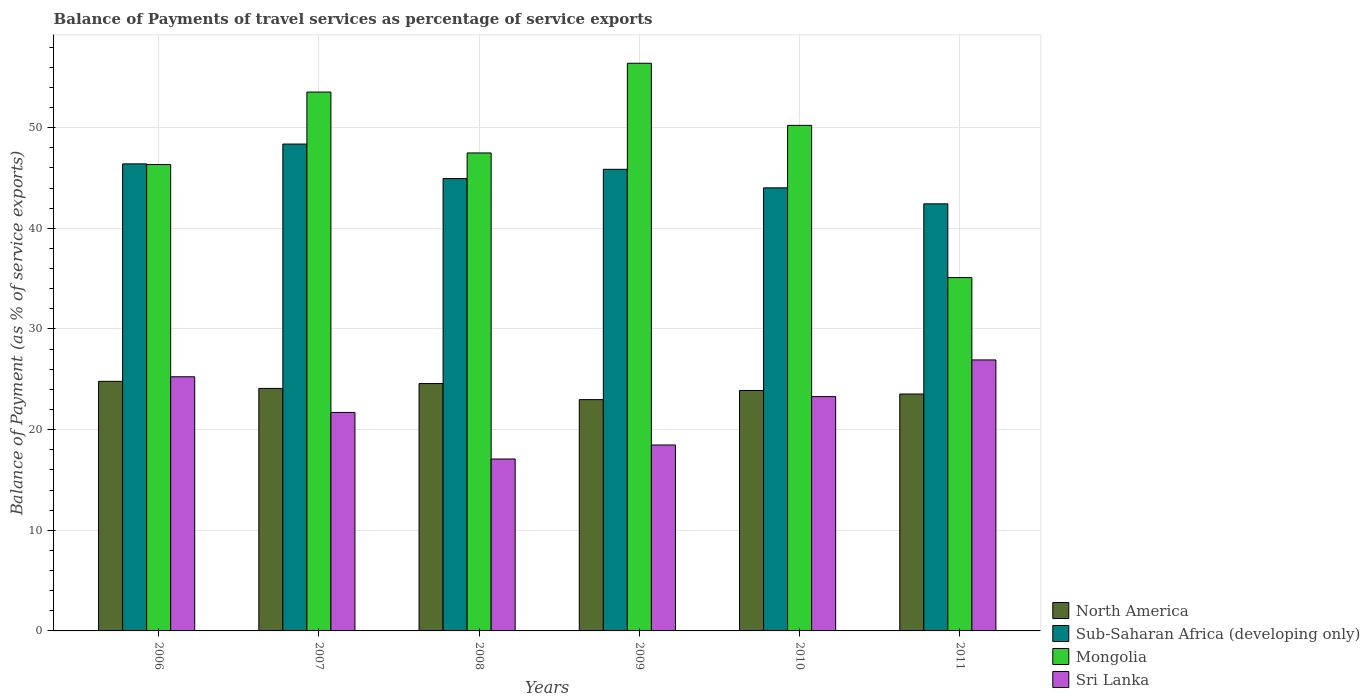How many different coloured bars are there?
Provide a short and direct response. 4. Are the number of bars per tick equal to the number of legend labels?
Make the answer very short. Yes. How many bars are there on the 1st tick from the right?
Offer a terse response. 4. In how many cases, is the number of bars for a given year not equal to the number of legend labels?
Your answer should be very brief. 0. What is the balance of payments of travel services in North America in 2009?
Provide a succinct answer. 22.98. Across all years, what is the maximum balance of payments of travel services in Sri Lanka?
Your answer should be compact. 26.92. Across all years, what is the minimum balance of payments of travel services in Sri Lanka?
Keep it short and to the point. 17.08. In which year was the balance of payments of travel services in Sub-Saharan Africa (developing only) maximum?
Provide a short and direct response. 2007. What is the total balance of payments of travel services in Sri Lanka in the graph?
Provide a succinct answer. 132.71. What is the difference between the balance of payments of travel services in Mongolia in 2007 and that in 2008?
Your answer should be very brief. 6.05. What is the difference between the balance of payments of travel services in Sub-Saharan Africa (developing only) in 2007 and the balance of payments of travel services in North America in 2009?
Provide a succinct answer. 25.39. What is the average balance of payments of travel services in North America per year?
Make the answer very short. 23.98. In the year 2009, what is the difference between the balance of payments of travel services in Mongolia and balance of payments of travel services in North America?
Your answer should be very brief. 33.42. In how many years, is the balance of payments of travel services in North America greater than 18 %?
Your answer should be compact. 6. What is the ratio of the balance of payments of travel services in Mongolia in 2006 to that in 2008?
Offer a very short reply. 0.98. Is the difference between the balance of payments of travel services in Mongolia in 2009 and 2010 greater than the difference between the balance of payments of travel services in North America in 2009 and 2010?
Ensure brevity in your answer.  Yes. What is the difference between the highest and the second highest balance of payments of travel services in Sri Lanka?
Provide a short and direct response. 1.67. What is the difference between the highest and the lowest balance of payments of travel services in Mongolia?
Offer a terse response. 21.29. Is the sum of the balance of payments of travel services in Sub-Saharan Africa (developing only) in 2007 and 2010 greater than the maximum balance of payments of travel services in North America across all years?
Offer a terse response. Yes. What does the 4th bar from the left in 2007 represents?
Offer a terse response. Sri Lanka. What does the 4th bar from the right in 2009 represents?
Your answer should be very brief. North America. Is it the case that in every year, the sum of the balance of payments of travel services in Sub-Saharan Africa (developing only) and balance of payments of travel services in Mongolia is greater than the balance of payments of travel services in North America?
Your response must be concise. Yes. How many bars are there?
Keep it short and to the point. 24. Are the values on the major ticks of Y-axis written in scientific E-notation?
Offer a terse response. No. Does the graph contain grids?
Provide a short and direct response. Yes. What is the title of the graph?
Your answer should be very brief. Balance of Payments of travel services as percentage of service exports. What is the label or title of the X-axis?
Keep it short and to the point. Years. What is the label or title of the Y-axis?
Offer a very short reply. Balance of Payment (as % of service exports). What is the Balance of Payment (as % of service exports) in North America in 2006?
Give a very brief answer. 24.8. What is the Balance of Payment (as % of service exports) of Sub-Saharan Africa (developing only) in 2006?
Offer a very short reply. 46.4. What is the Balance of Payment (as % of service exports) of Mongolia in 2006?
Make the answer very short. 46.34. What is the Balance of Payment (as % of service exports) in Sri Lanka in 2006?
Offer a very short reply. 25.25. What is the Balance of Payment (as % of service exports) in North America in 2007?
Make the answer very short. 24.1. What is the Balance of Payment (as % of service exports) in Sub-Saharan Africa (developing only) in 2007?
Give a very brief answer. 48.37. What is the Balance of Payment (as % of service exports) of Mongolia in 2007?
Offer a terse response. 53.54. What is the Balance of Payment (as % of service exports) in Sri Lanka in 2007?
Give a very brief answer. 21.71. What is the Balance of Payment (as % of service exports) in North America in 2008?
Keep it short and to the point. 24.58. What is the Balance of Payment (as % of service exports) in Sub-Saharan Africa (developing only) in 2008?
Ensure brevity in your answer.  44.94. What is the Balance of Payment (as % of service exports) of Mongolia in 2008?
Your response must be concise. 47.49. What is the Balance of Payment (as % of service exports) of Sri Lanka in 2008?
Make the answer very short. 17.08. What is the Balance of Payment (as % of service exports) in North America in 2009?
Offer a terse response. 22.98. What is the Balance of Payment (as % of service exports) in Sub-Saharan Africa (developing only) in 2009?
Provide a short and direct response. 45.86. What is the Balance of Payment (as % of service exports) of Mongolia in 2009?
Give a very brief answer. 56.4. What is the Balance of Payment (as % of service exports) in Sri Lanka in 2009?
Offer a terse response. 18.47. What is the Balance of Payment (as % of service exports) of North America in 2010?
Provide a short and direct response. 23.89. What is the Balance of Payment (as % of service exports) of Sub-Saharan Africa (developing only) in 2010?
Provide a short and direct response. 44.02. What is the Balance of Payment (as % of service exports) in Mongolia in 2010?
Your answer should be very brief. 50.23. What is the Balance of Payment (as % of service exports) in Sri Lanka in 2010?
Make the answer very short. 23.28. What is the Balance of Payment (as % of service exports) of North America in 2011?
Your response must be concise. 23.54. What is the Balance of Payment (as % of service exports) in Sub-Saharan Africa (developing only) in 2011?
Give a very brief answer. 42.43. What is the Balance of Payment (as % of service exports) in Mongolia in 2011?
Offer a terse response. 35.11. What is the Balance of Payment (as % of service exports) of Sri Lanka in 2011?
Your response must be concise. 26.92. Across all years, what is the maximum Balance of Payment (as % of service exports) of North America?
Provide a short and direct response. 24.8. Across all years, what is the maximum Balance of Payment (as % of service exports) of Sub-Saharan Africa (developing only)?
Ensure brevity in your answer.  48.37. Across all years, what is the maximum Balance of Payment (as % of service exports) in Mongolia?
Provide a short and direct response. 56.4. Across all years, what is the maximum Balance of Payment (as % of service exports) of Sri Lanka?
Offer a very short reply. 26.92. Across all years, what is the minimum Balance of Payment (as % of service exports) of North America?
Make the answer very short. 22.98. Across all years, what is the minimum Balance of Payment (as % of service exports) of Sub-Saharan Africa (developing only)?
Offer a terse response. 42.43. Across all years, what is the minimum Balance of Payment (as % of service exports) of Mongolia?
Give a very brief answer. 35.11. Across all years, what is the minimum Balance of Payment (as % of service exports) in Sri Lanka?
Offer a terse response. 17.08. What is the total Balance of Payment (as % of service exports) in North America in the graph?
Keep it short and to the point. 143.88. What is the total Balance of Payment (as % of service exports) of Sub-Saharan Africa (developing only) in the graph?
Your response must be concise. 272.03. What is the total Balance of Payment (as % of service exports) of Mongolia in the graph?
Your answer should be very brief. 289.1. What is the total Balance of Payment (as % of service exports) of Sri Lanka in the graph?
Your answer should be very brief. 132.71. What is the difference between the Balance of Payment (as % of service exports) in North America in 2006 and that in 2007?
Give a very brief answer. 0.7. What is the difference between the Balance of Payment (as % of service exports) of Sub-Saharan Africa (developing only) in 2006 and that in 2007?
Offer a terse response. -1.97. What is the difference between the Balance of Payment (as % of service exports) in Mongolia in 2006 and that in 2007?
Your answer should be very brief. -7.2. What is the difference between the Balance of Payment (as % of service exports) in Sri Lanka in 2006 and that in 2007?
Provide a short and direct response. 3.54. What is the difference between the Balance of Payment (as % of service exports) of North America in 2006 and that in 2008?
Offer a terse response. 0.22. What is the difference between the Balance of Payment (as % of service exports) of Sub-Saharan Africa (developing only) in 2006 and that in 2008?
Your answer should be very brief. 1.46. What is the difference between the Balance of Payment (as % of service exports) in Mongolia in 2006 and that in 2008?
Ensure brevity in your answer.  -1.15. What is the difference between the Balance of Payment (as % of service exports) of Sri Lanka in 2006 and that in 2008?
Your answer should be very brief. 8.17. What is the difference between the Balance of Payment (as % of service exports) in North America in 2006 and that in 2009?
Give a very brief answer. 1.82. What is the difference between the Balance of Payment (as % of service exports) in Sub-Saharan Africa (developing only) in 2006 and that in 2009?
Provide a succinct answer. 0.54. What is the difference between the Balance of Payment (as % of service exports) in Mongolia in 2006 and that in 2009?
Give a very brief answer. -10.06. What is the difference between the Balance of Payment (as % of service exports) of Sri Lanka in 2006 and that in 2009?
Keep it short and to the point. 6.78. What is the difference between the Balance of Payment (as % of service exports) in North America in 2006 and that in 2010?
Offer a terse response. 0.91. What is the difference between the Balance of Payment (as % of service exports) of Sub-Saharan Africa (developing only) in 2006 and that in 2010?
Provide a succinct answer. 2.38. What is the difference between the Balance of Payment (as % of service exports) in Mongolia in 2006 and that in 2010?
Ensure brevity in your answer.  -3.89. What is the difference between the Balance of Payment (as % of service exports) in Sri Lanka in 2006 and that in 2010?
Ensure brevity in your answer.  1.97. What is the difference between the Balance of Payment (as % of service exports) of North America in 2006 and that in 2011?
Your response must be concise. 1.26. What is the difference between the Balance of Payment (as % of service exports) in Sub-Saharan Africa (developing only) in 2006 and that in 2011?
Your answer should be very brief. 3.97. What is the difference between the Balance of Payment (as % of service exports) of Mongolia in 2006 and that in 2011?
Provide a succinct answer. 11.23. What is the difference between the Balance of Payment (as % of service exports) of Sri Lanka in 2006 and that in 2011?
Offer a very short reply. -1.67. What is the difference between the Balance of Payment (as % of service exports) of North America in 2007 and that in 2008?
Give a very brief answer. -0.48. What is the difference between the Balance of Payment (as % of service exports) of Sub-Saharan Africa (developing only) in 2007 and that in 2008?
Ensure brevity in your answer.  3.43. What is the difference between the Balance of Payment (as % of service exports) of Mongolia in 2007 and that in 2008?
Offer a terse response. 6.05. What is the difference between the Balance of Payment (as % of service exports) in Sri Lanka in 2007 and that in 2008?
Keep it short and to the point. 4.63. What is the difference between the Balance of Payment (as % of service exports) of North America in 2007 and that in 2009?
Give a very brief answer. 1.11. What is the difference between the Balance of Payment (as % of service exports) of Sub-Saharan Africa (developing only) in 2007 and that in 2009?
Make the answer very short. 2.51. What is the difference between the Balance of Payment (as % of service exports) of Mongolia in 2007 and that in 2009?
Offer a terse response. -2.86. What is the difference between the Balance of Payment (as % of service exports) of Sri Lanka in 2007 and that in 2009?
Provide a succinct answer. 3.23. What is the difference between the Balance of Payment (as % of service exports) of North America in 2007 and that in 2010?
Your answer should be compact. 0.21. What is the difference between the Balance of Payment (as % of service exports) of Sub-Saharan Africa (developing only) in 2007 and that in 2010?
Offer a very short reply. 4.35. What is the difference between the Balance of Payment (as % of service exports) of Mongolia in 2007 and that in 2010?
Give a very brief answer. 3.31. What is the difference between the Balance of Payment (as % of service exports) in Sri Lanka in 2007 and that in 2010?
Your answer should be very brief. -1.57. What is the difference between the Balance of Payment (as % of service exports) in North America in 2007 and that in 2011?
Provide a succinct answer. 0.56. What is the difference between the Balance of Payment (as % of service exports) in Sub-Saharan Africa (developing only) in 2007 and that in 2011?
Make the answer very short. 5.94. What is the difference between the Balance of Payment (as % of service exports) of Mongolia in 2007 and that in 2011?
Your answer should be very brief. 18.43. What is the difference between the Balance of Payment (as % of service exports) in Sri Lanka in 2007 and that in 2011?
Your answer should be compact. -5.22. What is the difference between the Balance of Payment (as % of service exports) of North America in 2008 and that in 2009?
Offer a terse response. 1.6. What is the difference between the Balance of Payment (as % of service exports) of Sub-Saharan Africa (developing only) in 2008 and that in 2009?
Give a very brief answer. -0.92. What is the difference between the Balance of Payment (as % of service exports) in Mongolia in 2008 and that in 2009?
Your answer should be very brief. -8.91. What is the difference between the Balance of Payment (as % of service exports) in Sri Lanka in 2008 and that in 2009?
Your answer should be compact. -1.39. What is the difference between the Balance of Payment (as % of service exports) of North America in 2008 and that in 2010?
Keep it short and to the point. 0.69. What is the difference between the Balance of Payment (as % of service exports) in Sub-Saharan Africa (developing only) in 2008 and that in 2010?
Offer a very short reply. 0.92. What is the difference between the Balance of Payment (as % of service exports) of Mongolia in 2008 and that in 2010?
Provide a succinct answer. -2.74. What is the difference between the Balance of Payment (as % of service exports) in Sri Lanka in 2008 and that in 2010?
Offer a terse response. -6.2. What is the difference between the Balance of Payment (as % of service exports) of North America in 2008 and that in 2011?
Your response must be concise. 1.04. What is the difference between the Balance of Payment (as % of service exports) in Sub-Saharan Africa (developing only) in 2008 and that in 2011?
Make the answer very short. 2.51. What is the difference between the Balance of Payment (as % of service exports) in Mongolia in 2008 and that in 2011?
Your response must be concise. 12.38. What is the difference between the Balance of Payment (as % of service exports) in Sri Lanka in 2008 and that in 2011?
Make the answer very short. -9.84. What is the difference between the Balance of Payment (as % of service exports) in North America in 2009 and that in 2010?
Make the answer very short. -0.91. What is the difference between the Balance of Payment (as % of service exports) in Sub-Saharan Africa (developing only) in 2009 and that in 2010?
Provide a succinct answer. 1.84. What is the difference between the Balance of Payment (as % of service exports) in Mongolia in 2009 and that in 2010?
Offer a very short reply. 6.17. What is the difference between the Balance of Payment (as % of service exports) in Sri Lanka in 2009 and that in 2010?
Offer a terse response. -4.8. What is the difference between the Balance of Payment (as % of service exports) of North America in 2009 and that in 2011?
Your response must be concise. -0.56. What is the difference between the Balance of Payment (as % of service exports) of Sub-Saharan Africa (developing only) in 2009 and that in 2011?
Your response must be concise. 3.43. What is the difference between the Balance of Payment (as % of service exports) of Mongolia in 2009 and that in 2011?
Your response must be concise. 21.29. What is the difference between the Balance of Payment (as % of service exports) of Sri Lanka in 2009 and that in 2011?
Your response must be concise. -8.45. What is the difference between the Balance of Payment (as % of service exports) of North America in 2010 and that in 2011?
Your response must be concise. 0.35. What is the difference between the Balance of Payment (as % of service exports) of Sub-Saharan Africa (developing only) in 2010 and that in 2011?
Your answer should be very brief. 1.59. What is the difference between the Balance of Payment (as % of service exports) in Mongolia in 2010 and that in 2011?
Ensure brevity in your answer.  15.12. What is the difference between the Balance of Payment (as % of service exports) of Sri Lanka in 2010 and that in 2011?
Offer a terse response. -3.65. What is the difference between the Balance of Payment (as % of service exports) of North America in 2006 and the Balance of Payment (as % of service exports) of Sub-Saharan Africa (developing only) in 2007?
Keep it short and to the point. -23.57. What is the difference between the Balance of Payment (as % of service exports) of North America in 2006 and the Balance of Payment (as % of service exports) of Mongolia in 2007?
Make the answer very short. -28.74. What is the difference between the Balance of Payment (as % of service exports) in North America in 2006 and the Balance of Payment (as % of service exports) in Sri Lanka in 2007?
Offer a terse response. 3.09. What is the difference between the Balance of Payment (as % of service exports) of Sub-Saharan Africa (developing only) in 2006 and the Balance of Payment (as % of service exports) of Mongolia in 2007?
Offer a terse response. -7.13. What is the difference between the Balance of Payment (as % of service exports) in Sub-Saharan Africa (developing only) in 2006 and the Balance of Payment (as % of service exports) in Sri Lanka in 2007?
Your answer should be very brief. 24.7. What is the difference between the Balance of Payment (as % of service exports) of Mongolia in 2006 and the Balance of Payment (as % of service exports) of Sri Lanka in 2007?
Your response must be concise. 24.63. What is the difference between the Balance of Payment (as % of service exports) in North America in 2006 and the Balance of Payment (as % of service exports) in Sub-Saharan Africa (developing only) in 2008?
Your answer should be very brief. -20.15. What is the difference between the Balance of Payment (as % of service exports) of North America in 2006 and the Balance of Payment (as % of service exports) of Mongolia in 2008?
Offer a very short reply. -22.69. What is the difference between the Balance of Payment (as % of service exports) of North America in 2006 and the Balance of Payment (as % of service exports) of Sri Lanka in 2008?
Provide a succinct answer. 7.72. What is the difference between the Balance of Payment (as % of service exports) in Sub-Saharan Africa (developing only) in 2006 and the Balance of Payment (as % of service exports) in Mongolia in 2008?
Provide a short and direct response. -1.09. What is the difference between the Balance of Payment (as % of service exports) in Sub-Saharan Africa (developing only) in 2006 and the Balance of Payment (as % of service exports) in Sri Lanka in 2008?
Keep it short and to the point. 29.32. What is the difference between the Balance of Payment (as % of service exports) of Mongolia in 2006 and the Balance of Payment (as % of service exports) of Sri Lanka in 2008?
Ensure brevity in your answer.  29.26. What is the difference between the Balance of Payment (as % of service exports) of North America in 2006 and the Balance of Payment (as % of service exports) of Sub-Saharan Africa (developing only) in 2009?
Keep it short and to the point. -21.07. What is the difference between the Balance of Payment (as % of service exports) of North America in 2006 and the Balance of Payment (as % of service exports) of Mongolia in 2009?
Your answer should be very brief. -31.6. What is the difference between the Balance of Payment (as % of service exports) in North America in 2006 and the Balance of Payment (as % of service exports) in Sri Lanka in 2009?
Keep it short and to the point. 6.32. What is the difference between the Balance of Payment (as % of service exports) in Sub-Saharan Africa (developing only) in 2006 and the Balance of Payment (as % of service exports) in Mongolia in 2009?
Provide a succinct answer. -10. What is the difference between the Balance of Payment (as % of service exports) of Sub-Saharan Africa (developing only) in 2006 and the Balance of Payment (as % of service exports) of Sri Lanka in 2009?
Your response must be concise. 27.93. What is the difference between the Balance of Payment (as % of service exports) in Mongolia in 2006 and the Balance of Payment (as % of service exports) in Sri Lanka in 2009?
Offer a very short reply. 27.86. What is the difference between the Balance of Payment (as % of service exports) of North America in 2006 and the Balance of Payment (as % of service exports) of Sub-Saharan Africa (developing only) in 2010?
Your answer should be very brief. -19.22. What is the difference between the Balance of Payment (as % of service exports) in North America in 2006 and the Balance of Payment (as % of service exports) in Mongolia in 2010?
Offer a very short reply. -25.43. What is the difference between the Balance of Payment (as % of service exports) in North America in 2006 and the Balance of Payment (as % of service exports) in Sri Lanka in 2010?
Offer a very short reply. 1.52. What is the difference between the Balance of Payment (as % of service exports) of Sub-Saharan Africa (developing only) in 2006 and the Balance of Payment (as % of service exports) of Mongolia in 2010?
Provide a short and direct response. -3.83. What is the difference between the Balance of Payment (as % of service exports) of Sub-Saharan Africa (developing only) in 2006 and the Balance of Payment (as % of service exports) of Sri Lanka in 2010?
Offer a terse response. 23.12. What is the difference between the Balance of Payment (as % of service exports) in Mongolia in 2006 and the Balance of Payment (as % of service exports) in Sri Lanka in 2010?
Offer a terse response. 23.06. What is the difference between the Balance of Payment (as % of service exports) of North America in 2006 and the Balance of Payment (as % of service exports) of Sub-Saharan Africa (developing only) in 2011?
Your answer should be compact. -17.64. What is the difference between the Balance of Payment (as % of service exports) of North America in 2006 and the Balance of Payment (as % of service exports) of Mongolia in 2011?
Your answer should be very brief. -10.31. What is the difference between the Balance of Payment (as % of service exports) of North America in 2006 and the Balance of Payment (as % of service exports) of Sri Lanka in 2011?
Ensure brevity in your answer.  -2.13. What is the difference between the Balance of Payment (as % of service exports) of Sub-Saharan Africa (developing only) in 2006 and the Balance of Payment (as % of service exports) of Mongolia in 2011?
Offer a terse response. 11.29. What is the difference between the Balance of Payment (as % of service exports) of Sub-Saharan Africa (developing only) in 2006 and the Balance of Payment (as % of service exports) of Sri Lanka in 2011?
Provide a short and direct response. 19.48. What is the difference between the Balance of Payment (as % of service exports) of Mongolia in 2006 and the Balance of Payment (as % of service exports) of Sri Lanka in 2011?
Provide a short and direct response. 19.41. What is the difference between the Balance of Payment (as % of service exports) of North America in 2007 and the Balance of Payment (as % of service exports) of Sub-Saharan Africa (developing only) in 2008?
Your answer should be compact. -20.85. What is the difference between the Balance of Payment (as % of service exports) of North America in 2007 and the Balance of Payment (as % of service exports) of Mongolia in 2008?
Your answer should be compact. -23.39. What is the difference between the Balance of Payment (as % of service exports) in North America in 2007 and the Balance of Payment (as % of service exports) in Sri Lanka in 2008?
Ensure brevity in your answer.  7.02. What is the difference between the Balance of Payment (as % of service exports) of Sub-Saharan Africa (developing only) in 2007 and the Balance of Payment (as % of service exports) of Mongolia in 2008?
Provide a short and direct response. 0.88. What is the difference between the Balance of Payment (as % of service exports) in Sub-Saharan Africa (developing only) in 2007 and the Balance of Payment (as % of service exports) in Sri Lanka in 2008?
Your answer should be very brief. 31.29. What is the difference between the Balance of Payment (as % of service exports) in Mongolia in 2007 and the Balance of Payment (as % of service exports) in Sri Lanka in 2008?
Keep it short and to the point. 36.46. What is the difference between the Balance of Payment (as % of service exports) of North America in 2007 and the Balance of Payment (as % of service exports) of Sub-Saharan Africa (developing only) in 2009?
Offer a terse response. -21.77. What is the difference between the Balance of Payment (as % of service exports) in North America in 2007 and the Balance of Payment (as % of service exports) in Mongolia in 2009?
Give a very brief answer. -32.3. What is the difference between the Balance of Payment (as % of service exports) in North America in 2007 and the Balance of Payment (as % of service exports) in Sri Lanka in 2009?
Make the answer very short. 5.62. What is the difference between the Balance of Payment (as % of service exports) in Sub-Saharan Africa (developing only) in 2007 and the Balance of Payment (as % of service exports) in Mongolia in 2009?
Keep it short and to the point. -8.03. What is the difference between the Balance of Payment (as % of service exports) of Sub-Saharan Africa (developing only) in 2007 and the Balance of Payment (as % of service exports) of Sri Lanka in 2009?
Your answer should be very brief. 29.9. What is the difference between the Balance of Payment (as % of service exports) in Mongolia in 2007 and the Balance of Payment (as % of service exports) in Sri Lanka in 2009?
Give a very brief answer. 35.06. What is the difference between the Balance of Payment (as % of service exports) of North America in 2007 and the Balance of Payment (as % of service exports) of Sub-Saharan Africa (developing only) in 2010?
Your answer should be compact. -19.92. What is the difference between the Balance of Payment (as % of service exports) in North America in 2007 and the Balance of Payment (as % of service exports) in Mongolia in 2010?
Ensure brevity in your answer.  -26.13. What is the difference between the Balance of Payment (as % of service exports) of North America in 2007 and the Balance of Payment (as % of service exports) of Sri Lanka in 2010?
Offer a very short reply. 0.82. What is the difference between the Balance of Payment (as % of service exports) in Sub-Saharan Africa (developing only) in 2007 and the Balance of Payment (as % of service exports) in Mongolia in 2010?
Your answer should be very brief. -1.86. What is the difference between the Balance of Payment (as % of service exports) of Sub-Saharan Africa (developing only) in 2007 and the Balance of Payment (as % of service exports) of Sri Lanka in 2010?
Offer a terse response. 25.09. What is the difference between the Balance of Payment (as % of service exports) in Mongolia in 2007 and the Balance of Payment (as % of service exports) in Sri Lanka in 2010?
Your answer should be very brief. 30.26. What is the difference between the Balance of Payment (as % of service exports) of North America in 2007 and the Balance of Payment (as % of service exports) of Sub-Saharan Africa (developing only) in 2011?
Provide a short and direct response. -18.34. What is the difference between the Balance of Payment (as % of service exports) of North America in 2007 and the Balance of Payment (as % of service exports) of Mongolia in 2011?
Your answer should be very brief. -11.01. What is the difference between the Balance of Payment (as % of service exports) of North America in 2007 and the Balance of Payment (as % of service exports) of Sri Lanka in 2011?
Provide a succinct answer. -2.83. What is the difference between the Balance of Payment (as % of service exports) in Sub-Saharan Africa (developing only) in 2007 and the Balance of Payment (as % of service exports) in Mongolia in 2011?
Give a very brief answer. 13.26. What is the difference between the Balance of Payment (as % of service exports) of Sub-Saharan Africa (developing only) in 2007 and the Balance of Payment (as % of service exports) of Sri Lanka in 2011?
Offer a terse response. 21.45. What is the difference between the Balance of Payment (as % of service exports) in Mongolia in 2007 and the Balance of Payment (as % of service exports) in Sri Lanka in 2011?
Keep it short and to the point. 26.61. What is the difference between the Balance of Payment (as % of service exports) in North America in 2008 and the Balance of Payment (as % of service exports) in Sub-Saharan Africa (developing only) in 2009?
Offer a very short reply. -21.29. What is the difference between the Balance of Payment (as % of service exports) of North America in 2008 and the Balance of Payment (as % of service exports) of Mongolia in 2009?
Provide a succinct answer. -31.82. What is the difference between the Balance of Payment (as % of service exports) in North America in 2008 and the Balance of Payment (as % of service exports) in Sri Lanka in 2009?
Your response must be concise. 6.1. What is the difference between the Balance of Payment (as % of service exports) of Sub-Saharan Africa (developing only) in 2008 and the Balance of Payment (as % of service exports) of Mongolia in 2009?
Your answer should be very brief. -11.45. What is the difference between the Balance of Payment (as % of service exports) in Sub-Saharan Africa (developing only) in 2008 and the Balance of Payment (as % of service exports) in Sri Lanka in 2009?
Make the answer very short. 26.47. What is the difference between the Balance of Payment (as % of service exports) in Mongolia in 2008 and the Balance of Payment (as % of service exports) in Sri Lanka in 2009?
Offer a terse response. 29.01. What is the difference between the Balance of Payment (as % of service exports) in North America in 2008 and the Balance of Payment (as % of service exports) in Sub-Saharan Africa (developing only) in 2010?
Keep it short and to the point. -19.44. What is the difference between the Balance of Payment (as % of service exports) in North America in 2008 and the Balance of Payment (as % of service exports) in Mongolia in 2010?
Keep it short and to the point. -25.65. What is the difference between the Balance of Payment (as % of service exports) in North America in 2008 and the Balance of Payment (as % of service exports) in Sri Lanka in 2010?
Keep it short and to the point. 1.3. What is the difference between the Balance of Payment (as % of service exports) in Sub-Saharan Africa (developing only) in 2008 and the Balance of Payment (as % of service exports) in Mongolia in 2010?
Keep it short and to the point. -5.29. What is the difference between the Balance of Payment (as % of service exports) in Sub-Saharan Africa (developing only) in 2008 and the Balance of Payment (as % of service exports) in Sri Lanka in 2010?
Offer a very short reply. 21.67. What is the difference between the Balance of Payment (as % of service exports) of Mongolia in 2008 and the Balance of Payment (as % of service exports) of Sri Lanka in 2010?
Your answer should be very brief. 24.21. What is the difference between the Balance of Payment (as % of service exports) of North America in 2008 and the Balance of Payment (as % of service exports) of Sub-Saharan Africa (developing only) in 2011?
Ensure brevity in your answer.  -17.86. What is the difference between the Balance of Payment (as % of service exports) in North America in 2008 and the Balance of Payment (as % of service exports) in Mongolia in 2011?
Give a very brief answer. -10.53. What is the difference between the Balance of Payment (as % of service exports) of North America in 2008 and the Balance of Payment (as % of service exports) of Sri Lanka in 2011?
Ensure brevity in your answer.  -2.35. What is the difference between the Balance of Payment (as % of service exports) in Sub-Saharan Africa (developing only) in 2008 and the Balance of Payment (as % of service exports) in Mongolia in 2011?
Make the answer very short. 9.84. What is the difference between the Balance of Payment (as % of service exports) in Sub-Saharan Africa (developing only) in 2008 and the Balance of Payment (as % of service exports) in Sri Lanka in 2011?
Your answer should be very brief. 18.02. What is the difference between the Balance of Payment (as % of service exports) in Mongolia in 2008 and the Balance of Payment (as % of service exports) in Sri Lanka in 2011?
Offer a terse response. 20.56. What is the difference between the Balance of Payment (as % of service exports) of North America in 2009 and the Balance of Payment (as % of service exports) of Sub-Saharan Africa (developing only) in 2010?
Ensure brevity in your answer.  -21.04. What is the difference between the Balance of Payment (as % of service exports) in North America in 2009 and the Balance of Payment (as % of service exports) in Mongolia in 2010?
Your answer should be compact. -27.25. What is the difference between the Balance of Payment (as % of service exports) of North America in 2009 and the Balance of Payment (as % of service exports) of Sri Lanka in 2010?
Keep it short and to the point. -0.3. What is the difference between the Balance of Payment (as % of service exports) of Sub-Saharan Africa (developing only) in 2009 and the Balance of Payment (as % of service exports) of Mongolia in 2010?
Ensure brevity in your answer.  -4.37. What is the difference between the Balance of Payment (as % of service exports) in Sub-Saharan Africa (developing only) in 2009 and the Balance of Payment (as % of service exports) in Sri Lanka in 2010?
Provide a short and direct response. 22.58. What is the difference between the Balance of Payment (as % of service exports) in Mongolia in 2009 and the Balance of Payment (as % of service exports) in Sri Lanka in 2010?
Keep it short and to the point. 33.12. What is the difference between the Balance of Payment (as % of service exports) in North America in 2009 and the Balance of Payment (as % of service exports) in Sub-Saharan Africa (developing only) in 2011?
Make the answer very short. -19.45. What is the difference between the Balance of Payment (as % of service exports) of North America in 2009 and the Balance of Payment (as % of service exports) of Mongolia in 2011?
Offer a terse response. -12.13. What is the difference between the Balance of Payment (as % of service exports) in North America in 2009 and the Balance of Payment (as % of service exports) in Sri Lanka in 2011?
Give a very brief answer. -3.94. What is the difference between the Balance of Payment (as % of service exports) in Sub-Saharan Africa (developing only) in 2009 and the Balance of Payment (as % of service exports) in Mongolia in 2011?
Offer a terse response. 10.75. What is the difference between the Balance of Payment (as % of service exports) in Sub-Saharan Africa (developing only) in 2009 and the Balance of Payment (as % of service exports) in Sri Lanka in 2011?
Your response must be concise. 18.94. What is the difference between the Balance of Payment (as % of service exports) of Mongolia in 2009 and the Balance of Payment (as % of service exports) of Sri Lanka in 2011?
Offer a terse response. 29.47. What is the difference between the Balance of Payment (as % of service exports) in North America in 2010 and the Balance of Payment (as % of service exports) in Sub-Saharan Africa (developing only) in 2011?
Your response must be concise. -18.54. What is the difference between the Balance of Payment (as % of service exports) in North America in 2010 and the Balance of Payment (as % of service exports) in Mongolia in 2011?
Your response must be concise. -11.22. What is the difference between the Balance of Payment (as % of service exports) in North America in 2010 and the Balance of Payment (as % of service exports) in Sri Lanka in 2011?
Offer a terse response. -3.04. What is the difference between the Balance of Payment (as % of service exports) in Sub-Saharan Africa (developing only) in 2010 and the Balance of Payment (as % of service exports) in Mongolia in 2011?
Your response must be concise. 8.91. What is the difference between the Balance of Payment (as % of service exports) in Sub-Saharan Africa (developing only) in 2010 and the Balance of Payment (as % of service exports) in Sri Lanka in 2011?
Your response must be concise. 17.1. What is the difference between the Balance of Payment (as % of service exports) of Mongolia in 2010 and the Balance of Payment (as % of service exports) of Sri Lanka in 2011?
Provide a succinct answer. 23.31. What is the average Balance of Payment (as % of service exports) of North America per year?
Offer a very short reply. 23.98. What is the average Balance of Payment (as % of service exports) of Sub-Saharan Africa (developing only) per year?
Keep it short and to the point. 45.34. What is the average Balance of Payment (as % of service exports) of Mongolia per year?
Ensure brevity in your answer.  48.18. What is the average Balance of Payment (as % of service exports) in Sri Lanka per year?
Your answer should be very brief. 22.12. In the year 2006, what is the difference between the Balance of Payment (as % of service exports) of North America and Balance of Payment (as % of service exports) of Sub-Saharan Africa (developing only)?
Provide a short and direct response. -21.61. In the year 2006, what is the difference between the Balance of Payment (as % of service exports) in North America and Balance of Payment (as % of service exports) in Mongolia?
Offer a very short reply. -21.54. In the year 2006, what is the difference between the Balance of Payment (as % of service exports) of North America and Balance of Payment (as % of service exports) of Sri Lanka?
Give a very brief answer. -0.45. In the year 2006, what is the difference between the Balance of Payment (as % of service exports) in Sub-Saharan Africa (developing only) and Balance of Payment (as % of service exports) in Mongolia?
Give a very brief answer. 0.07. In the year 2006, what is the difference between the Balance of Payment (as % of service exports) in Sub-Saharan Africa (developing only) and Balance of Payment (as % of service exports) in Sri Lanka?
Your answer should be compact. 21.15. In the year 2006, what is the difference between the Balance of Payment (as % of service exports) of Mongolia and Balance of Payment (as % of service exports) of Sri Lanka?
Make the answer very short. 21.09. In the year 2007, what is the difference between the Balance of Payment (as % of service exports) in North America and Balance of Payment (as % of service exports) in Sub-Saharan Africa (developing only)?
Make the answer very short. -24.28. In the year 2007, what is the difference between the Balance of Payment (as % of service exports) of North America and Balance of Payment (as % of service exports) of Mongolia?
Offer a terse response. -29.44. In the year 2007, what is the difference between the Balance of Payment (as % of service exports) in North America and Balance of Payment (as % of service exports) in Sri Lanka?
Your answer should be very brief. 2.39. In the year 2007, what is the difference between the Balance of Payment (as % of service exports) in Sub-Saharan Africa (developing only) and Balance of Payment (as % of service exports) in Mongolia?
Your answer should be compact. -5.17. In the year 2007, what is the difference between the Balance of Payment (as % of service exports) of Sub-Saharan Africa (developing only) and Balance of Payment (as % of service exports) of Sri Lanka?
Your response must be concise. 26.66. In the year 2007, what is the difference between the Balance of Payment (as % of service exports) in Mongolia and Balance of Payment (as % of service exports) in Sri Lanka?
Your answer should be compact. 31.83. In the year 2008, what is the difference between the Balance of Payment (as % of service exports) in North America and Balance of Payment (as % of service exports) in Sub-Saharan Africa (developing only)?
Provide a succinct answer. -20.37. In the year 2008, what is the difference between the Balance of Payment (as % of service exports) of North America and Balance of Payment (as % of service exports) of Mongolia?
Your answer should be compact. -22.91. In the year 2008, what is the difference between the Balance of Payment (as % of service exports) in North America and Balance of Payment (as % of service exports) in Sri Lanka?
Make the answer very short. 7.5. In the year 2008, what is the difference between the Balance of Payment (as % of service exports) of Sub-Saharan Africa (developing only) and Balance of Payment (as % of service exports) of Mongolia?
Offer a very short reply. -2.54. In the year 2008, what is the difference between the Balance of Payment (as % of service exports) of Sub-Saharan Africa (developing only) and Balance of Payment (as % of service exports) of Sri Lanka?
Give a very brief answer. 27.86. In the year 2008, what is the difference between the Balance of Payment (as % of service exports) in Mongolia and Balance of Payment (as % of service exports) in Sri Lanka?
Offer a very short reply. 30.41. In the year 2009, what is the difference between the Balance of Payment (as % of service exports) in North America and Balance of Payment (as % of service exports) in Sub-Saharan Africa (developing only)?
Give a very brief answer. -22.88. In the year 2009, what is the difference between the Balance of Payment (as % of service exports) of North America and Balance of Payment (as % of service exports) of Mongolia?
Make the answer very short. -33.42. In the year 2009, what is the difference between the Balance of Payment (as % of service exports) in North America and Balance of Payment (as % of service exports) in Sri Lanka?
Your answer should be very brief. 4.51. In the year 2009, what is the difference between the Balance of Payment (as % of service exports) in Sub-Saharan Africa (developing only) and Balance of Payment (as % of service exports) in Mongolia?
Offer a terse response. -10.54. In the year 2009, what is the difference between the Balance of Payment (as % of service exports) of Sub-Saharan Africa (developing only) and Balance of Payment (as % of service exports) of Sri Lanka?
Your answer should be very brief. 27.39. In the year 2009, what is the difference between the Balance of Payment (as % of service exports) of Mongolia and Balance of Payment (as % of service exports) of Sri Lanka?
Give a very brief answer. 37.92. In the year 2010, what is the difference between the Balance of Payment (as % of service exports) of North America and Balance of Payment (as % of service exports) of Sub-Saharan Africa (developing only)?
Provide a succinct answer. -20.13. In the year 2010, what is the difference between the Balance of Payment (as % of service exports) of North America and Balance of Payment (as % of service exports) of Mongolia?
Give a very brief answer. -26.34. In the year 2010, what is the difference between the Balance of Payment (as % of service exports) in North America and Balance of Payment (as % of service exports) in Sri Lanka?
Your response must be concise. 0.61. In the year 2010, what is the difference between the Balance of Payment (as % of service exports) in Sub-Saharan Africa (developing only) and Balance of Payment (as % of service exports) in Mongolia?
Give a very brief answer. -6.21. In the year 2010, what is the difference between the Balance of Payment (as % of service exports) of Sub-Saharan Africa (developing only) and Balance of Payment (as % of service exports) of Sri Lanka?
Your response must be concise. 20.74. In the year 2010, what is the difference between the Balance of Payment (as % of service exports) of Mongolia and Balance of Payment (as % of service exports) of Sri Lanka?
Give a very brief answer. 26.95. In the year 2011, what is the difference between the Balance of Payment (as % of service exports) of North America and Balance of Payment (as % of service exports) of Sub-Saharan Africa (developing only)?
Your response must be concise. -18.89. In the year 2011, what is the difference between the Balance of Payment (as % of service exports) in North America and Balance of Payment (as % of service exports) in Mongolia?
Your answer should be compact. -11.57. In the year 2011, what is the difference between the Balance of Payment (as % of service exports) of North America and Balance of Payment (as % of service exports) of Sri Lanka?
Ensure brevity in your answer.  -3.39. In the year 2011, what is the difference between the Balance of Payment (as % of service exports) of Sub-Saharan Africa (developing only) and Balance of Payment (as % of service exports) of Mongolia?
Provide a succinct answer. 7.33. In the year 2011, what is the difference between the Balance of Payment (as % of service exports) of Sub-Saharan Africa (developing only) and Balance of Payment (as % of service exports) of Sri Lanka?
Give a very brief answer. 15.51. In the year 2011, what is the difference between the Balance of Payment (as % of service exports) of Mongolia and Balance of Payment (as % of service exports) of Sri Lanka?
Offer a terse response. 8.18. What is the ratio of the Balance of Payment (as % of service exports) in North America in 2006 to that in 2007?
Make the answer very short. 1.03. What is the ratio of the Balance of Payment (as % of service exports) of Sub-Saharan Africa (developing only) in 2006 to that in 2007?
Offer a terse response. 0.96. What is the ratio of the Balance of Payment (as % of service exports) of Mongolia in 2006 to that in 2007?
Give a very brief answer. 0.87. What is the ratio of the Balance of Payment (as % of service exports) in Sri Lanka in 2006 to that in 2007?
Offer a terse response. 1.16. What is the ratio of the Balance of Payment (as % of service exports) of Sub-Saharan Africa (developing only) in 2006 to that in 2008?
Keep it short and to the point. 1.03. What is the ratio of the Balance of Payment (as % of service exports) of Mongolia in 2006 to that in 2008?
Provide a succinct answer. 0.98. What is the ratio of the Balance of Payment (as % of service exports) in Sri Lanka in 2006 to that in 2008?
Your answer should be compact. 1.48. What is the ratio of the Balance of Payment (as % of service exports) of North America in 2006 to that in 2009?
Give a very brief answer. 1.08. What is the ratio of the Balance of Payment (as % of service exports) of Sub-Saharan Africa (developing only) in 2006 to that in 2009?
Offer a terse response. 1.01. What is the ratio of the Balance of Payment (as % of service exports) in Mongolia in 2006 to that in 2009?
Provide a short and direct response. 0.82. What is the ratio of the Balance of Payment (as % of service exports) of Sri Lanka in 2006 to that in 2009?
Ensure brevity in your answer.  1.37. What is the ratio of the Balance of Payment (as % of service exports) in North America in 2006 to that in 2010?
Keep it short and to the point. 1.04. What is the ratio of the Balance of Payment (as % of service exports) in Sub-Saharan Africa (developing only) in 2006 to that in 2010?
Offer a terse response. 1.05. What is the ratio of the Balance of Payment (as % of service exports) of Mongolia in 2006 to that in 2010?
Your answer should be very brief. 0.92. What is the ratio of the Balance of Payment (as % of service exports) of Sri Lanka in 2006 to that in 2010?
Your answer should be very brief. 1.08. What is the ratio of the Balance of Payment (as % of service exports) of North America in 2006 to that in 2011?
Provide a short and direct response. 1.05. What is the ratio of the Balance of Payment (as % of service exports) of Sub-Saharan Africa (developing only) in 2006 to that in 2011?
Your response must be concise. 1.09. What is the ratio of the Balance of Payment (as % of service exports) of Mongolia in 2006 to that in 2011?
Offer a very short reply. 1.32. What is the ratio of the Balance of Payment (as % of service exports) in Sri Lanka in 2006 to that in 2011?
Provide a short and direct response. 0.94. What is the ratio of the Balance of Payment (as % of service exports) of North America in 2007 to that in 2008?
Your answer should be very brief. 0.98. What is the ratio of the Balance of Payment (as % of service exports) in Sub-Saharan Africa (developing only) in 2007 to that in 2008?
Provide a succinct answer. 1.08. What is the ratio of the Balance of Payment (as % of service exports) of Mongolia in 2007 to that in 2008?
Provide a succinct answer. 1.13. What is the ratio of the Balance of Payment (as % of service exports) of Sri Lanka in 2007 to that in 2008?
Keep it short and to the point. 1.27. What is the ratio of the Balance of Payment (as % of service exports) of North America in 2007 to that in 2009?
Your answer should be very brief. 1.05. What is the ratio of the Balance of Payment (as % of service exports) in Sub-Saharan Africa (developing only) in 2007 to that in 2009?
Give a very brief answer. 1.05. What is the ratio of the Balance of Payment (as % of service exports) in Mongolia in 2007 to that in 2009?
Make the answer very short. 0.95. What is the ratio of the Balance of Payment (as % of service exports) of Sri Lanka in 2007 to that in 2009?
Your answer should be very brief. 1.18. What is the ratio of the Balance of Payment (as % of service exports) of North America in 2007 to that in 2010?
Offer a terse response. 1.01. What is the ratio of the Balance of Payment (as % of service exports) in Sub-Saharan Africa (developing only) in 2007 to that in 2010?
Offer a very short reply. 1.1. What is the ratio of the Balance of Payment (as % of service exports) in Mongolia in 2007 to that in 2010?
Offer a terse response. 1.07. What is the ratio of the Balance of Payment (as % of service exports) in Sri Lanka in 2007 to that in 2010?
Provide a short and direct response. 0.93. What is the ratio of the Balance of Payment (as % of service exports) in North America in 2007 to that in 2011?
Offer a very short reply. 1.02. What is the ratio of the Balance of Payment (as % of service exports) in Sub-Saharan Africa (developing only) in 2007 to that in 2011?
Your response must be concise. 1.14. What is the ratio of the Balance of Payment (as % of service exports) of Mongolia in 2007 to that in 2011?
Provide a succinct answer. 1.52. What is the ratio of the Balance of Payment (as % of service exports) of Sri Lanka in 2007 to that in 2011?
Ensure brevity in your answer.  0.81. What is the ratio of the Balance of Payment (as % of service exports) in North America in 2008 to that in 2009?
Ensure brevity in your answer.  1.07. What is the ratio of the Balance of Payment (as % of service exports) in Mongolia in 2008 to that in 2009?
Offer a terse response. 0.84. What is the ratio of the Balance of Payment (as % of service exports) of Sri Lanka in 2008 to that in 2009?
Your response must be concise. 0.92. What is the ratio of the Balance of Payment (as % of service exports) in North America in 2008 to that in 2010?
Your answer should be very brief. 1.03. What is the ratio of the Balance of Payment (as % of service exports) of Mongolia in 2008 to that in 2010?
Your response must be concise. 0.95. What is the ratio of the Balance of Payment (as % of service exports) in Sri Lanka in 2008 to that in 2010?
Offer a very short reply. 0.73. What is the ratio of the Balance of Payment (as % of service exports) of North America in 2008 to that in 2011?
Keep it short and to the point. 1.04. What is the ratio of the Balance of Payment (as % of service exports) in Sub-Saharan Africa (developing only) in 2008 to that in 2011?
Your answer should be compact. 1.06. What is the ratio of the Balance of Payment (as % of service exports) in Mongolia in 2008 to that in 2011?
Ensure brevity in your answer.  1.35. What is the ratio of the Balance of Payment (as % of service exports) in Sri Lanka in 2008 to that in 2011?
Offer a very short reply. 0.63. What is the ratio of the Balance of Payment (as % of service exports) of Sub-Saharan Africa (developing only) in 2009 to that in 2010?
Provide a succinct answer. 1.04. What is the ratio of the Balance of Payment (as % of service exports) in Mongolia in 2009 to that in 2010?
Provide a short and direct response. 1.12. What is the ratio of the Balance of Payment (as % of service exports) in Sri Lanka in 2009 to that in 2010?
Give a very brief answer. 0.79. What is the ratio of the Balance of Payment (as % of service exports) in North America in 2009 to that in 2011?
Give a very brief answer. 0.98. What is the ratio of the Balance of Payment (as % of service exports) of Sub-Saharan Africa (developing only) in 2009 to that in 2011?
Ensure brevity in your answer.  1.08. What is the ratio of the Balance of Payment (as % of service exports) in Mongolia in 2009 to that in 2011?
Provide a succinct answer. 1.61. What is the ratio of the Balance of Payment (as % of service exports) in Sri Lanka in 2009 to that in 2011?
Ensure brevity in your answer.  0.69. What is the ratio of the Balance of Payment (as % of service exports) in North America in 2010 to that in 2011?
Give a very brief answer. 1.01. What is the ratio of the Balance of Payment (as % of service exports) in Sub-Saharan Africa (developing only) in 2010 to that in 2011?
Make the answer very short. 1.04. What is the ratio of the Balance of Payment (as % of service exports) of Mongolia in 2010 to that in 2011?
Offer a very short reply. 1.43. What is the ratio of the Balance of Payment (as % of service exports) in Sri Lanka in 2010 to that in 2011?
Keep it short and to the point. 0.86. What is the difference between the highest and the second highest Balance of Payment (as % of service exports) in North America?
Ensure brevity in your answer.  0.22. What is the difference between the highest and the second highest Balance of Payment (as % of service exports) of Sub-Saharan Africa (developing only)?
Your answer should be compact. 1.97. What is the difference between the highest and the second highest Balance of Payment (as % of service exports) in Mongolia?
Give a very brief answer. 2.86. What is the difference between the highest and the second highest Balance of Payment (as % of service exports) of Sri Lanka?
Provide a succinct answer. 1.67. What is the difference between the highest and the lowest Balance of Payment (as % of service exports) in North America?
Offer a terse response. 1.82. What is the difference between the highest and the lowest Balance of Payment (as % of service exports) in Sub-Saharan Africa (developing only)?
Your answer should be very brief. 5.94. What is the difference between the highest and the lowest Balance of Payment (as % of service exports) in Mongolia?
Offer a very short reply. 21.29. What is the difference between the highest and the lowest Balance of Payment (as % of service exports) of Sri Lanka?
Make the answer very short. 9.84. 